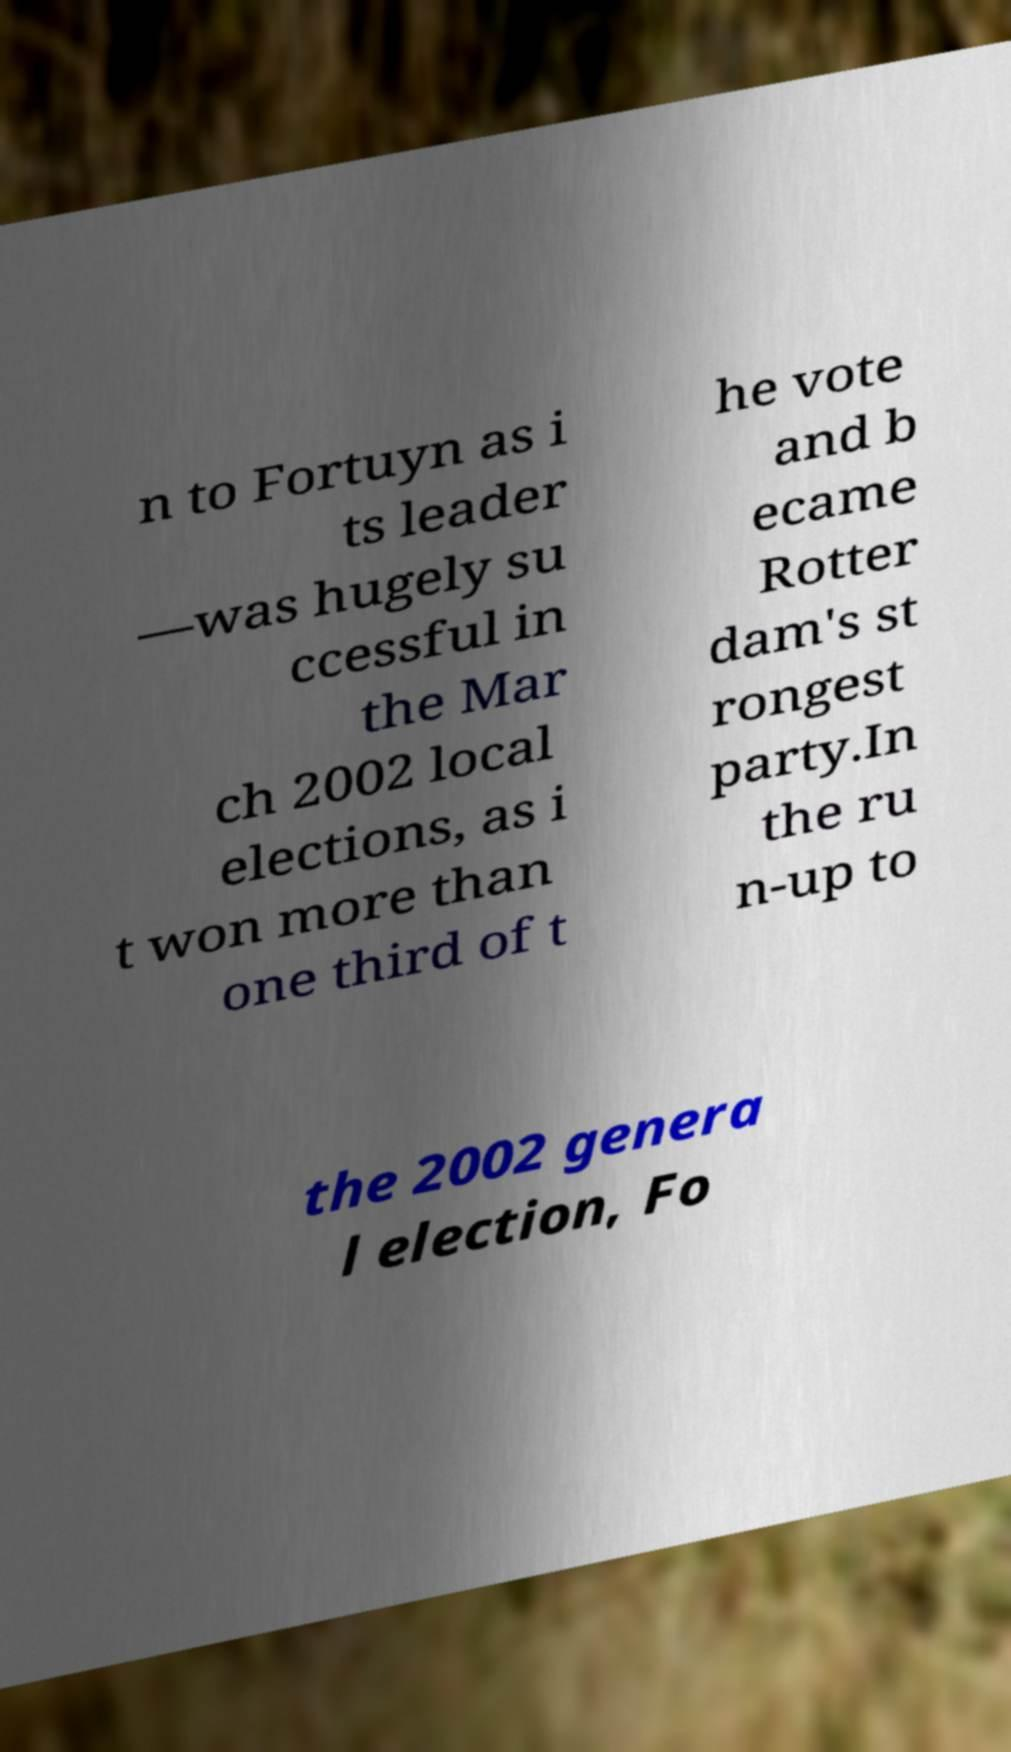There's text embedded in this image that I need extracted. Can you transcribe it verbatim? n to Fortuyn as i ts leader —was hugely su ccessful in the Mar ch 2002 local elections, as i t won more than one third of t he vote and b ecame Rotter dam's st rongest party.In the ru n-up to the 2002 genera l election, Fo 